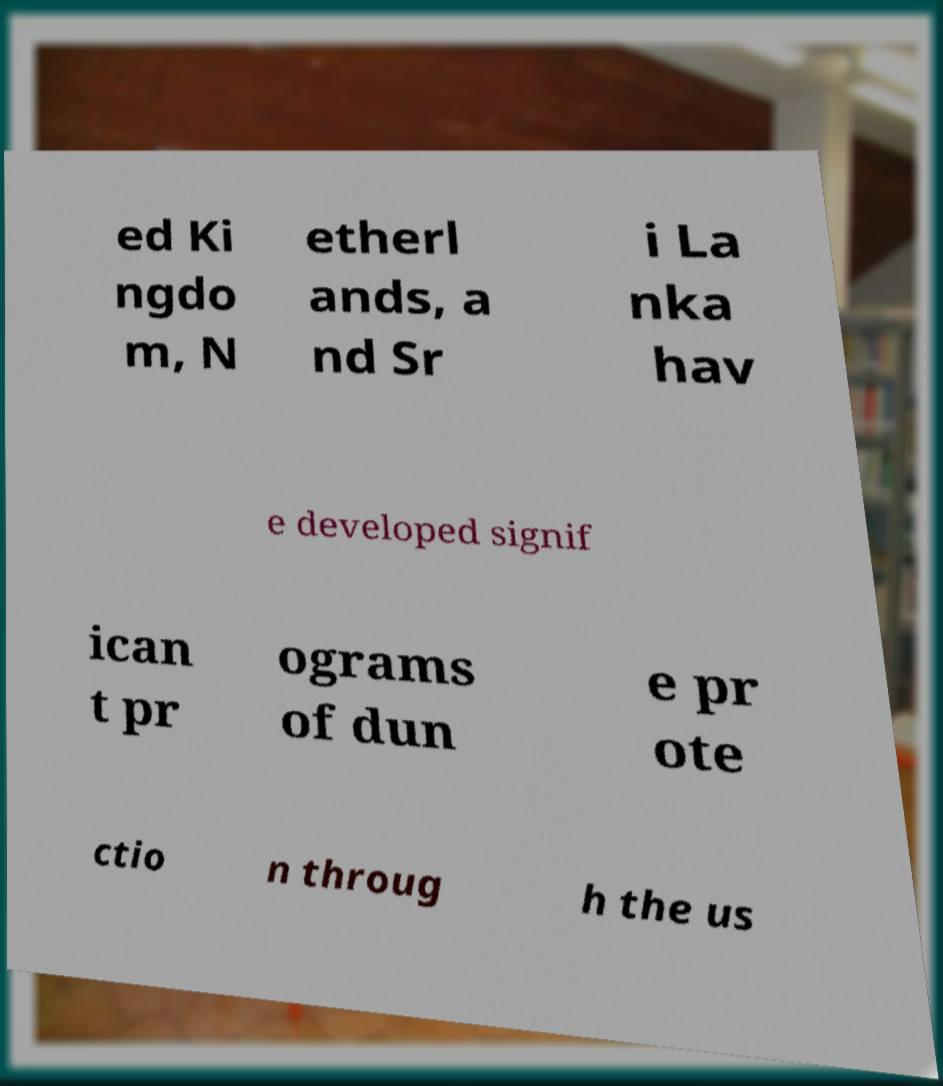Can you accurately transcribe the text from the provided image for me? ed Ki ngdo m, N etherl ands, a nd Sr i La nka hav e developed signif ican t pr ograms of dun e pr ote ctio n throug h the us 